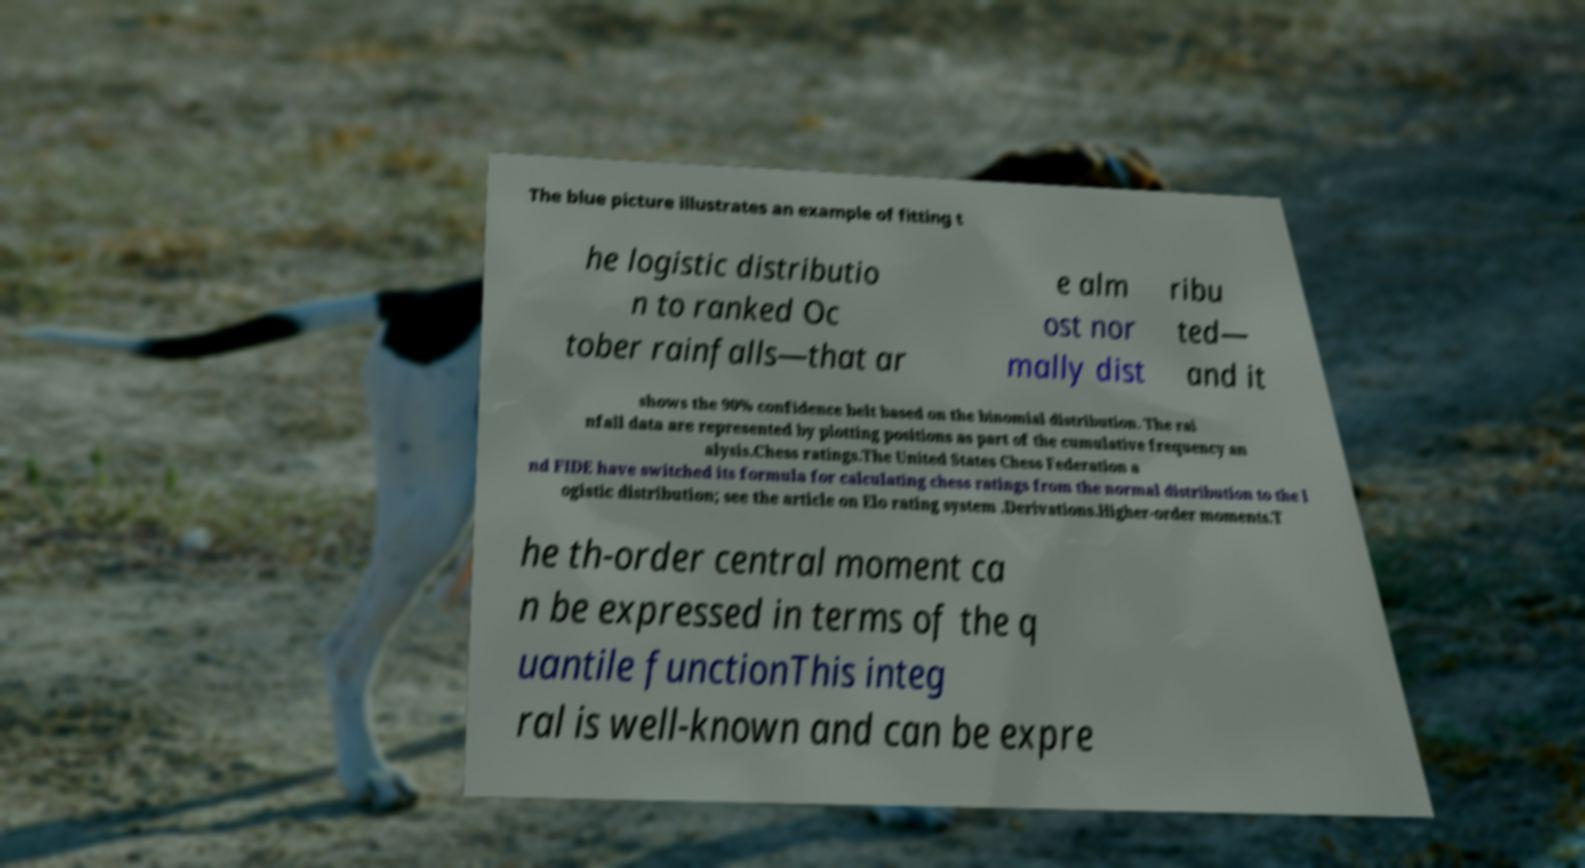Could you extract and type out the text from this image? The blue picture illustrates an example of fitting t he logistic distributio n to ranked Oc tober rainfalls—that ar e alm ost nor mally dist ribu ted— and it shows the 90% confidence belt based on the binomial distribution. The rai nfall data are represented by plotting positions as part of the cumulative frequency an alysis.Chess ratings.The United States Chess Federation a nd FIDE have switched its formula for calculating chess ratings from the normal distribution to the l ogistic distribution; see the article on Elo rating system .Derivations.Higher-order moments.T he th-order central moment ca n be expressed in terms of the q uantile functionThis integ ral is well-known and can be expre 